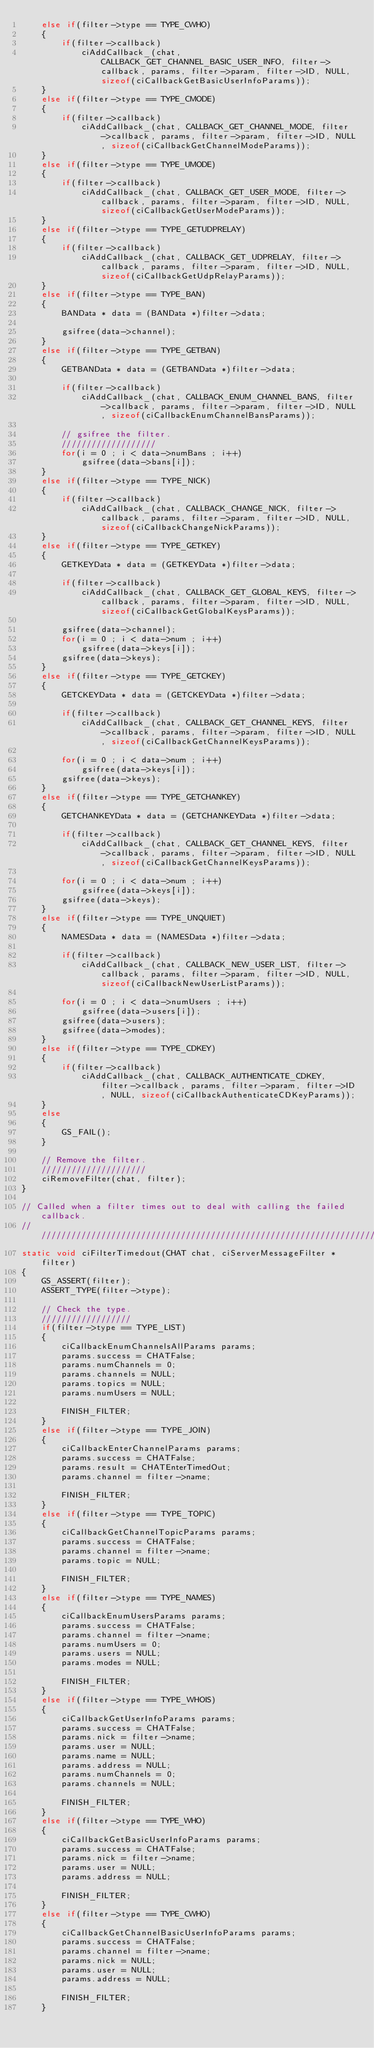Convert code to text. <code><loc_0><loc_0><loc_500><loc_500><_C_>	else if(filter->type == TYPE_CWHO)
	{
		if(filter->callback)
			ciAddCallback_(chat, CALLBACK_GET_CHANNEL_BASIC_USER_INFO, filter->callback, params, filter->param, filter->ID, NULL, sizeof(ciCallbackGetBasicUserInfoParams));
	}
	else if(filter->type == TYPE_CMODE)
	{
		if(filter->callback)
			ciAddCallback_(chat, CALLBACK_GET_CHANNEL_MODE, filter->callback, params, filter->param, filter->ID, NULL, sizeof(ciCallbackGetChannelModeParams));
	}
	else if(filter->type == TYPE_UMODE)
	{
		if(filter->callback)
			ciAddCallback_(chat, CALLBACK_GET_USER_MODE, filter->callback, params, filter->param, filter->ID, NULL, sizeof(ciCallbackGetUserModeParams));
	}
	else if(filter->type == TYPE_GETUDPRELAY)
	{
		if(filter->callback)
			ciAddCallback_(chat, CALLBACK_GET_UDPRELAY, filter->callback, params, filter->param, filter->ID, NULL, sizeof(ciCallbackGetUdpRelayParams));
	}
	else if(filter->type == TYPE_BAN)
	{
		BANData * data = (BANData *)filter->data;

		gsifree(data->channel);
	}
	else if(filter->type == TYPE_GETBAN)
	{
		GETBANData * data = (GETBANData *)filter->data;

		if(filter->callback)
			ciAddCallback_(chat, CALLBACK_ENUM_CHANNEL_BANS, filter->callback, params, filter->param, filter->ID, NULL, sizeof(ciCallbackEnumChannelBansParams));

		// gsifree the filter.
		///////////////////
		for(i = 0 ; i < data->numBans ; i++)
			gsifree(data->bans[i]);
	}
	else if(filter->type == TYPE_NICK)
	{
		if(filter->callback)
			ciAddCallback_(chat, CALLBACK_CHANGE_NICK, filter->callback, params, filter->param, filter->ID, NULL, sizeof(ciCallbackChangeNickParams));
	}
	else if(filter->type == TYPE_GETKEY)
	{
		GETKEYData * data = (GETKEYData *)filter->data;

		if(filter->callback)
			ciAddCallback_(chat, CALLBACK_GET_GLOBAL_KEYS, filter->callback, params, filter->param, filter->ID, NULL, sizeof(ciCallbackGetGlobalKeysParams));

		gsifree(data->channel);
		for(i = 0 ; i < data->num ; i++)
			gsifree(data->keys[i]);
		gsifree(data->keys);
	}
	else if(filter->type == TYPE_GETCKEY)
	{
		GETCKEYData * data = (GETCKEYData *)filter->data;

		if(filter->callback)
			ciAddCallback_(chat, CALLBACK_GET_CHANNEL_KEYS, filter->callback, params, filter->param, filter->ID, NULL, sizeof(ciCallbackGetChannelKeysParams));

		for(i = 0 ; i < data->num ; i++)
			gsifree(data->keys[i]);
		gsifree(data->keys);
	}
	else if(filter->type == TYPE_GETCHANKEY)
	{
		GETCHANKEYData * data = (GETCHANKEYData *)filter->data;

		if(filter->callback)
			ciAddCallback_(chat, CALLBACK_GET_CHANNEL_KEYS, filter->callback, params, filter->param, filter->ID, NULL, sizeof(ciCallbackGetChannelKeysParams));

		for(i = 0 ; i < data->num ; i++)
			gsifree(data->keys[i]);
		gsifree(data->keys);
	}
	else if(filter->type == TYPE_UNQUIET)
	{
		NAMESData * data = (NAMESData *)filter->data;

		if(filter->callback)
			ciAddCallback_(chat, CALLBACK_NEW_USER_LIST, filter->callback, params, filter->param, filter->ID, NULL, sizeof(ciCallbackNewUserListParams));

		for(i = 0 ; i < data->numUsers ; i++)
			gsifree(data->users[i]);
		gsifree(data->users);
		gsifree(data->modes);
	}
	else if(filter->type == TYPE_CDKEY)
	{
		if(filter->callback)
			ciAddCallback_(chat, CALLBACK_AUTHENTICATE_CDKEY, filter->callback, params, filter->param, filter->ID, NULL, sizeof(ciCallbackAuthenticateCDKeyParams));
	}
	else
	{
		GS_FAIL();
	}

	// Remove the filter.
	/////////////////////
	ciRemoveFilter(chat, filter);
}

// Called when a filter times out to deal with calling the failed callback.
///////////////////////////////////////////////////////////////////////////
static void ciFilterTimedout(CHAT chat, ciServerMessageFilter * filter)
{
	GS_ASSERT(filter);
	ASSERT_TYPE(filter->type);
	
	// Check the type.
	//////////////////
	if(filter->type == TYPE_LIST)
	{
		ciCallbackEnumChannelsAllParams params;
		params.success = CHATFalse;
		params.numChannels = 0;
		params.channels = NULL;
		params.topics = NULL;
		params.numUsers = NULL;

		FINISH_FILTER;
	}
	else if(filter->type == TYPE_JOIN)
	{
		ciCallbackEnterChannelParams params;
		params.success = CHATFalse;
		params.result = CHATEnterTimedOut;
		params.channel = filter->name;

		FINISH_FILTER;
	}
	else if(filter->type == TYPE_TOPIC)
	{
		ciCallbackGetChannelTopicParams params;
		params.success = CHATFalse;
		params.channel = filter->name;
		params.topic = NULL;

		FINISH_FILTER;
	}
	else if(filter->type == TYPE_NAMES)
	{
		ciCallbackEnumUsersParams params;
		params.success = CHATFalse;
		params.channel = filter->name;
		params.numUsers = 0;
		params.users = NULL;
		params.modes = NULL;

		FINISH_FILTER;
	}
	else if(filter->type == TYPE_WHOIS)
	{
		ciCallbackGetUserInfoParams params;
		params.success = CHATFalse;
		params.nick = filter->name;
		params.user = NULL;
		params.name = NULL;
		params.address = NULL;
		params.numChannels = 0;
		params.channels = NULL;

		FINISH_FILTER;
	}
	else if(filter->type == TYPE_WHO)
	{
		ciCallbackGetBasicUserInfoParams params;
		params.success = CHATFalse;
		params.nick = filter->name;
		params.user = NULL;
		params.address = NULL;

		FINISH_FILTER;
	}
	else if(filter->type == TYPE_CWHO)
	{
		ciCallbackGetChannelBasicUserInfoParams params;
		params.success = CHATFalse;
		params.channel = filter->name;
		params.nick = NULL;
		params.user = NULL;
		params.address = NULL;

		FINISH_FILTER;
	}</code> 